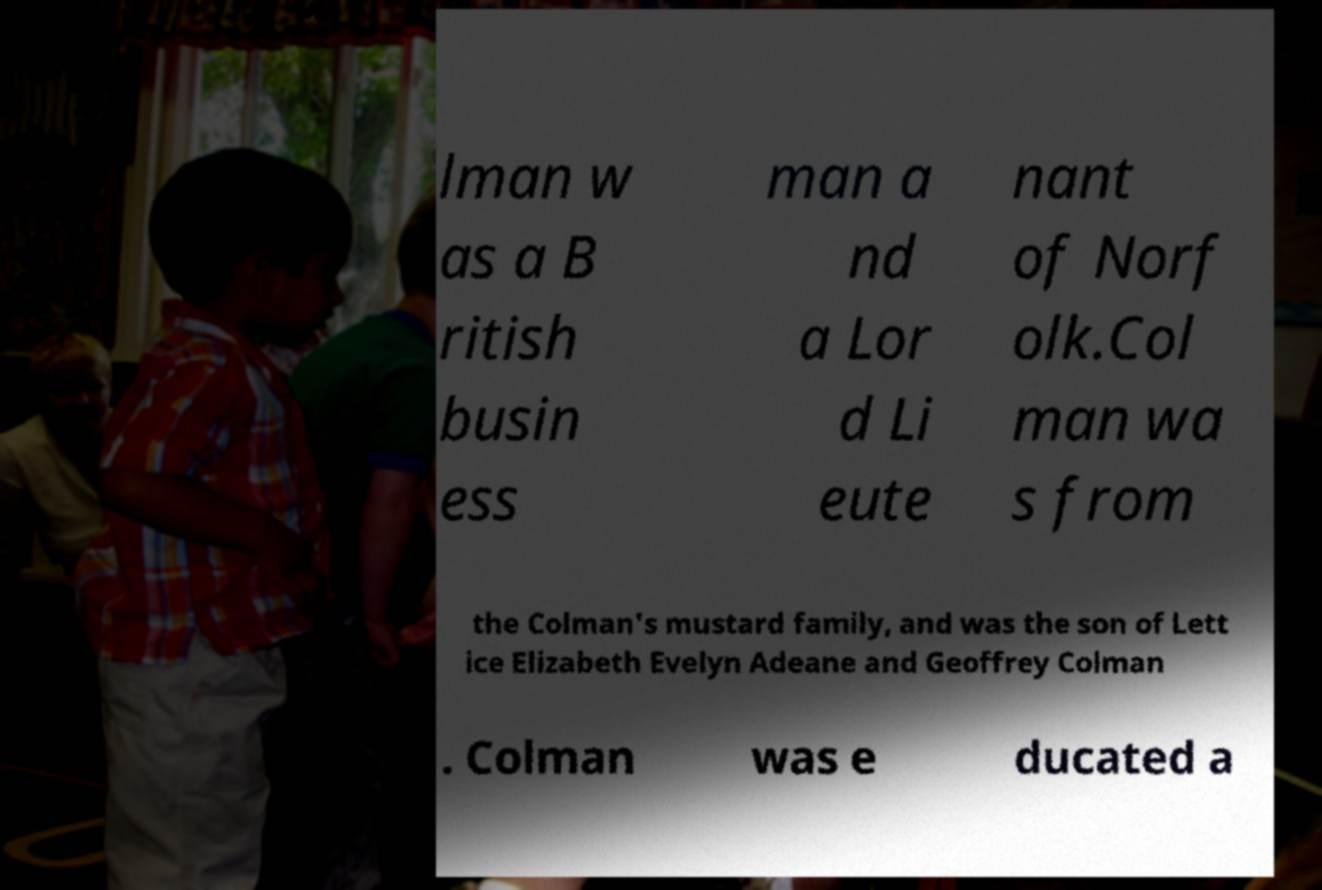Please identify and transcribe the text found in this image. lman w as a B ritish busin ess man a nd a Lor d Li eute nant of Norf olk.Col man wa s from the Colman's mustard family, and was the son of Lett ice Elizabeth Evelyn Adeane and Geoffrey Colman . Colman was e ducated a 